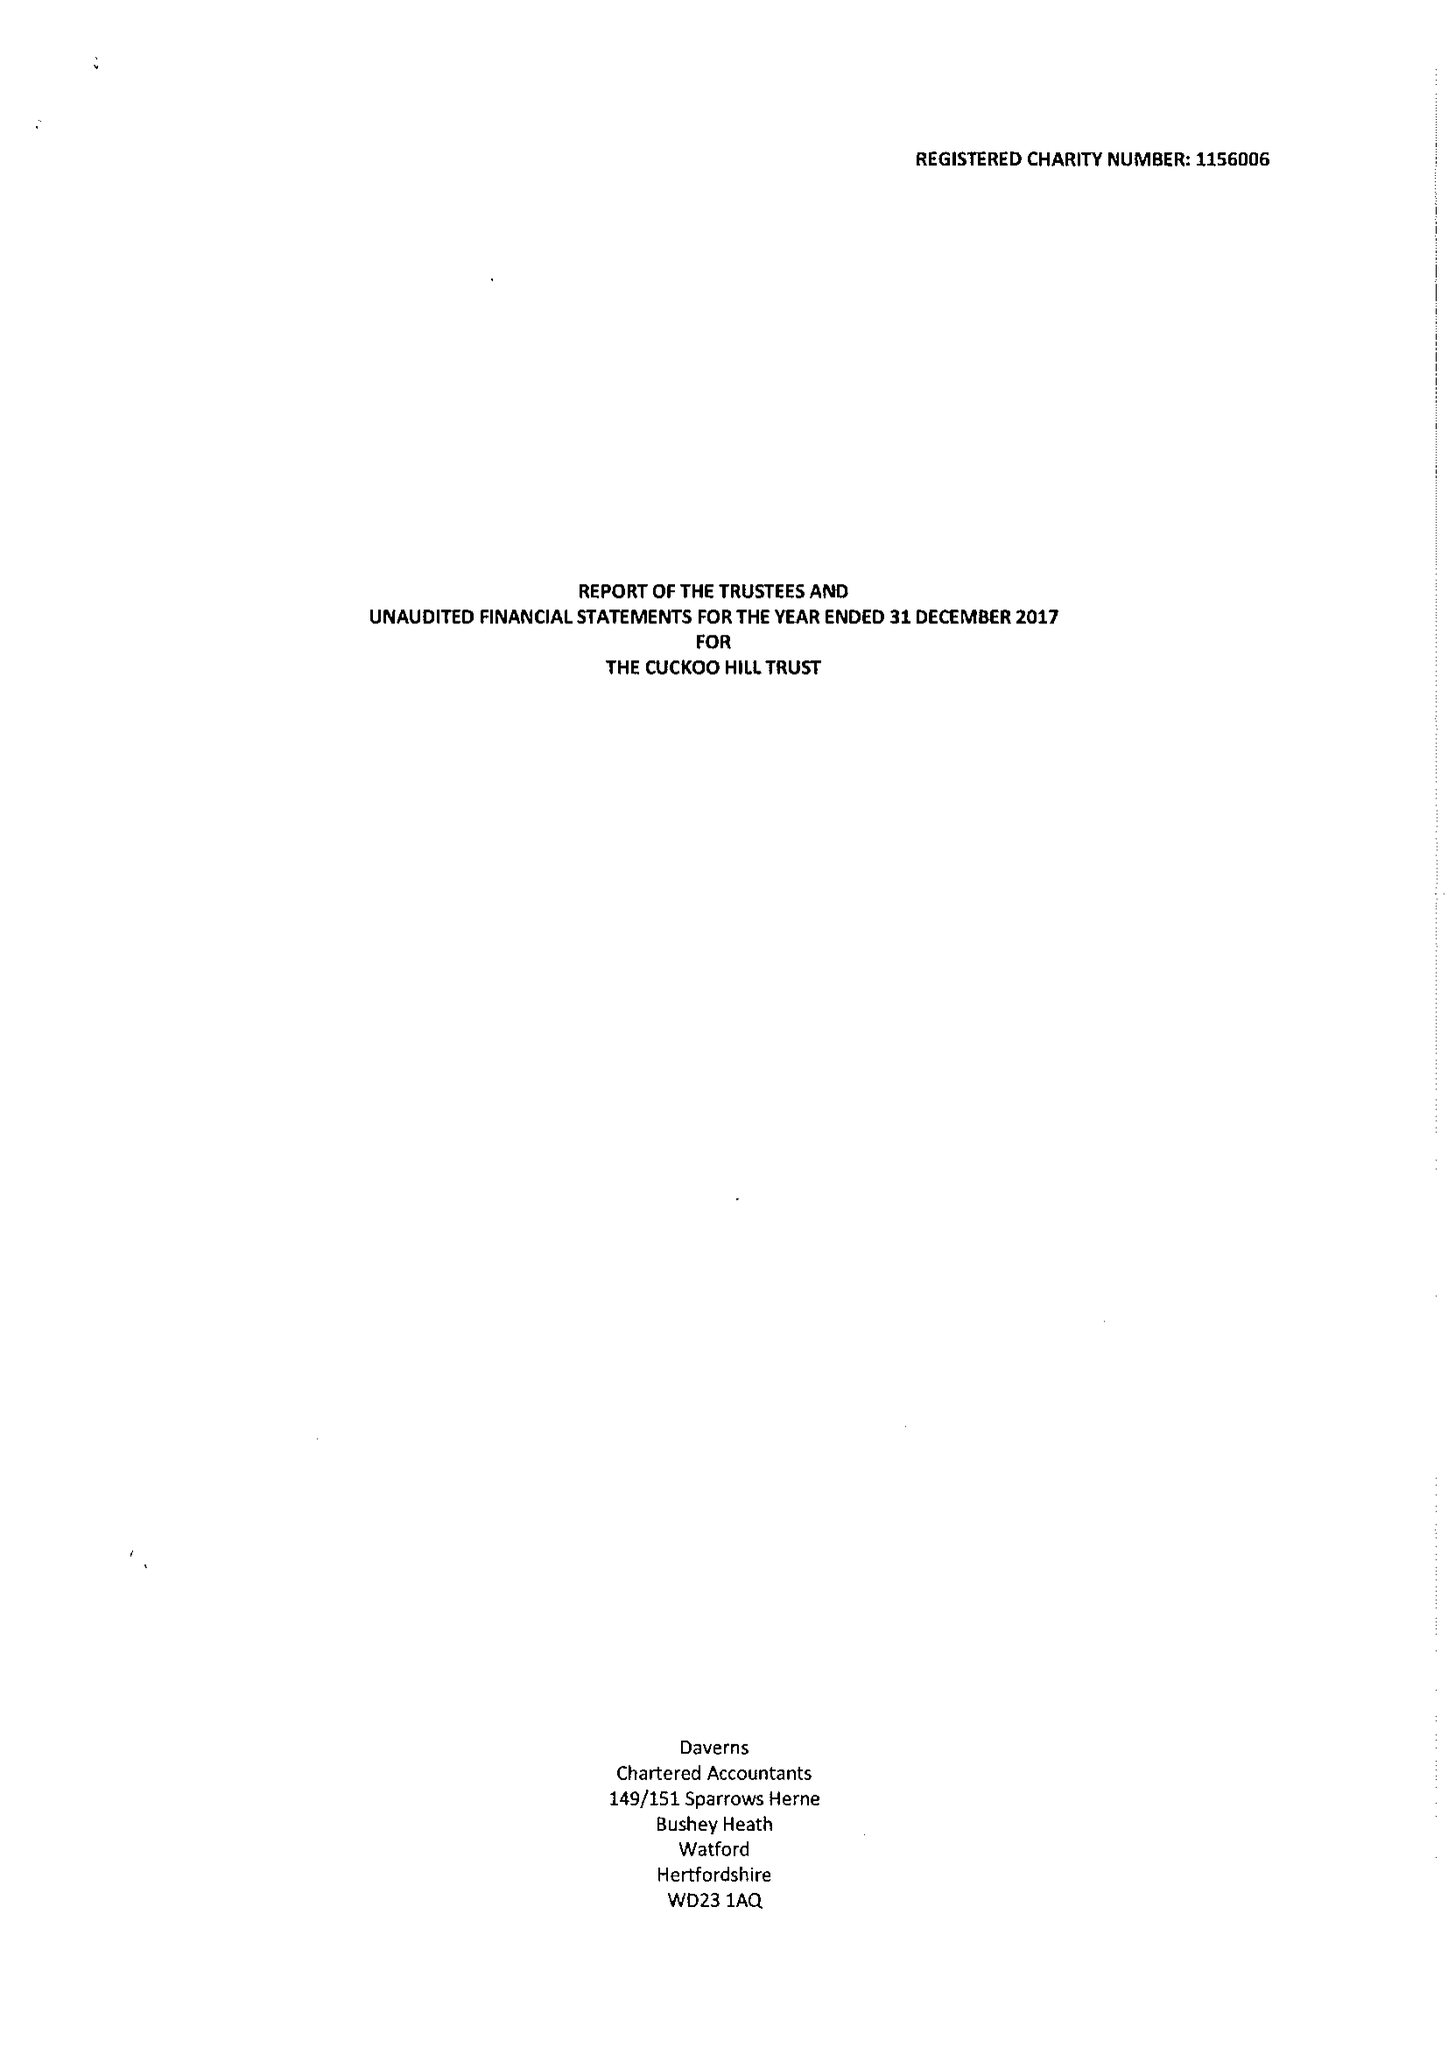What is the value for the charity_name?
Answer the question using a single word or phrase. The Cuckoo Hill Trust 